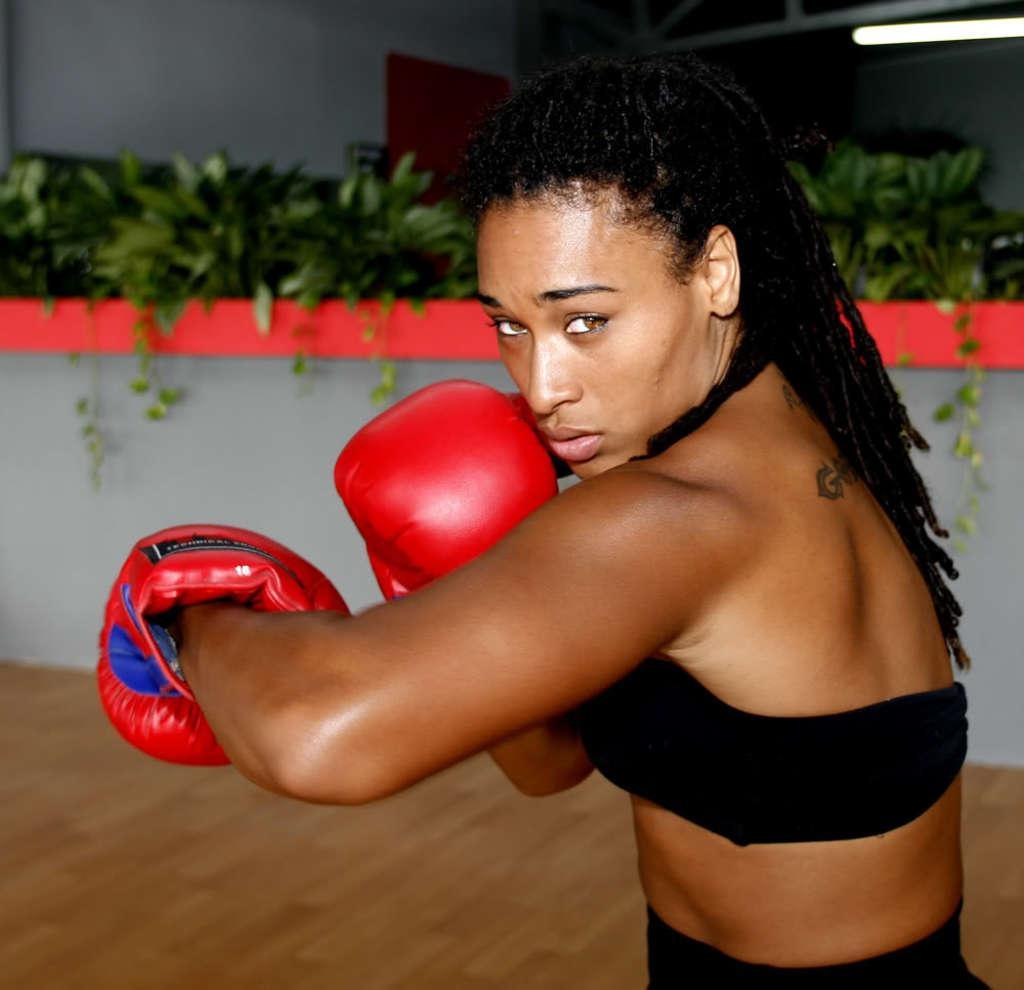In one or two sentences, can you explain what this image depicts? In this image we can see a woman with long hair is wearing boxing gloves on her hands is standing on the floor. In the background, we can see group of plants, metal frame and a light. 